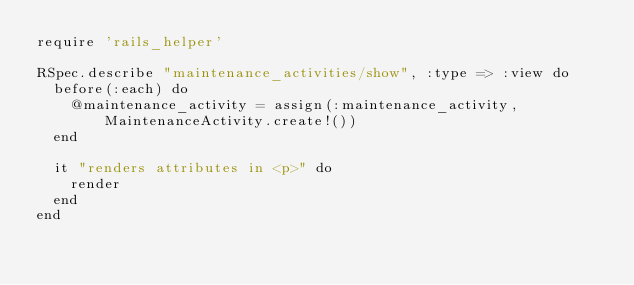<code> <loc_0><loc_0><loc_500><loc_500><_Ruby_>require 'rails_helper'

RSpec.describe "maintenance_activities/show", :type => :view do
  before(:each) do
    @maintenance_activity = assign(:maintenance_activity, MaintenanceActivity.create!())
  end

  it "renders attributes in <p>" do
    render
  end
end
</code> 